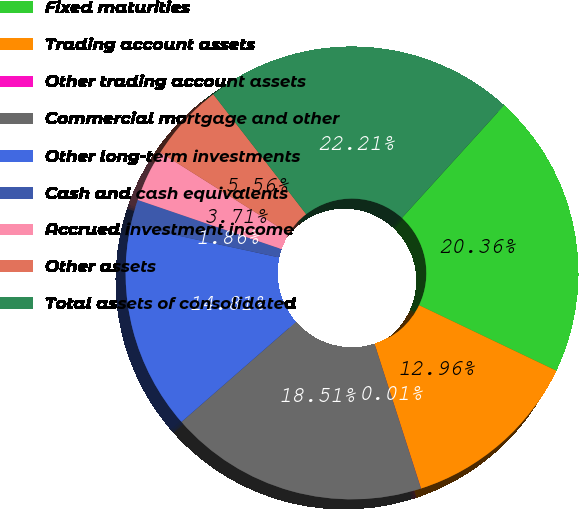Convert chart to OTSL. <chart><loc_0><loc_0><loc_500><loc_500><pie_chart><fcel>Fixed maturities<fcel>Trading account assets<fcel>Other trading account assets<fcel>Commercial mortgage and other<fcel>Other long-term investments<fcel>Cash and cash equivalents<fcel>Accrued investment income<fcel>Other assets<fcel>Total assets of consolidated<nl><fcel>20.36%<fcel>12.96%<fcel>0.01%<fcel>18.51%<fcel>14.81%<fcel>1.86%<fcel>3.71%<fcel>5.56%<fcel>22.21%<nl></chart> 